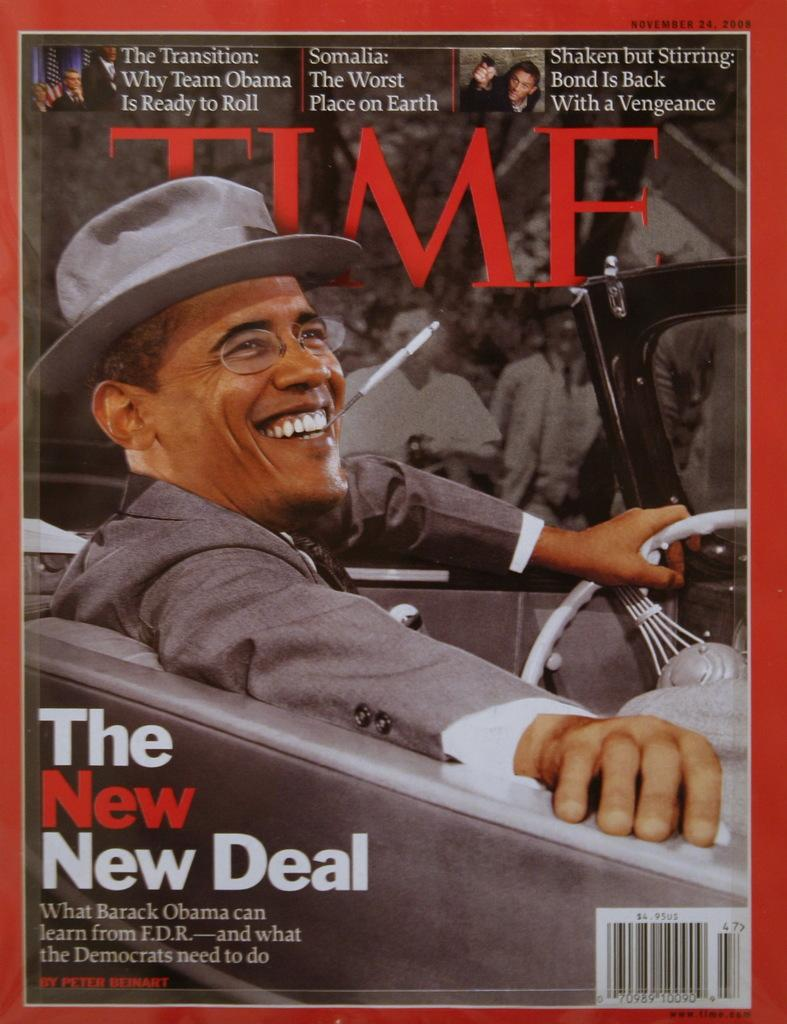What is featured in the image? There is a poster and a person sitting in a car in the image. Can you describe the poster in the image? Unfortunately, the provided facts do not give any details about the poster, so we cannot describe it. What is the person in the car doing? The facts do not specify what the person is doing in the car, so we cannot determine their actions. What type of bell can be heard ringing in the image? There is no bell present in the image, so we cannot hear it ringing. Is the person's uncle sitting in the car with them in the image? The facts do not mention any relationship between the person and the person sitting in the car, so we cannot determine if the person's uncle is present. 